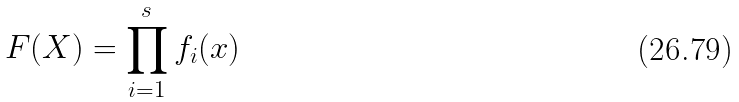<formula> <loc_0><loc_0><loc_500><loc_500>F ( X ) = \prod _ { i = 1 } ^ { s } f _ { i } ( x )</formula> 